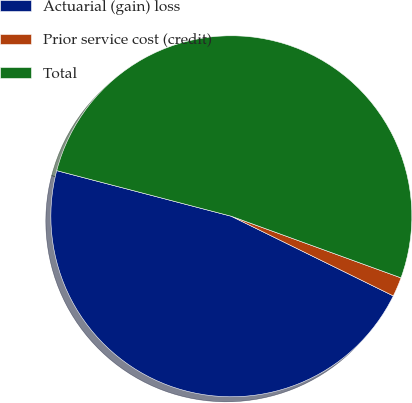Convert chart. <chart><loc_0><loc_0><loc_500><loc_500><pie_chart><fcel>Actuarial (gain) loss<fcel>Prior service cost (credit)<fcel>Total<nl><fcel>46.79%<fcel>1.73%<fcel>51.47%<nl></chart> 